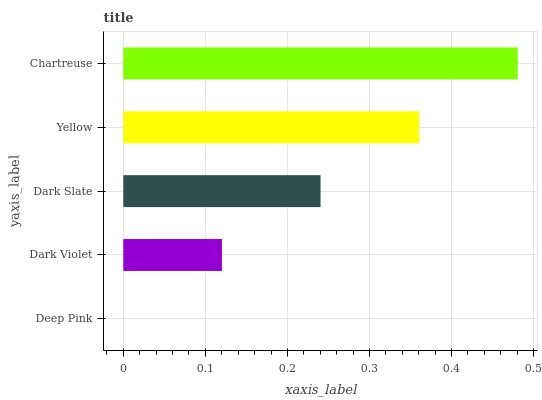Is Deep Pink the minimum?
Answer yes or no. Yes. Is Chartreuse the maximum?
Answer yes or no. Yes. Is Dark Violet the minimum?
Answer yes or no. No. Is Dark Violet the maximum?
Answer yes or no. No. Is Dark Violet greater than Deep Pink?
Answer yes or no. Yes. Is Deep Pink less than Dark Violet?
Answer yes or no. Yes. Is Deep Pink greater than Dark Violet?
Answer yes or no. No. Is Dark Violet less than Deep Pink?
Answer yes or no. No. Is Dark Slate the high median?
Answer yes or no. Yes. Is Dark Slate the low median?
Answer yes or no. Yes. Is Yellow the high median?
Answer yes or no. No. Is Yellow the low median?
Answer yes or no. No. 